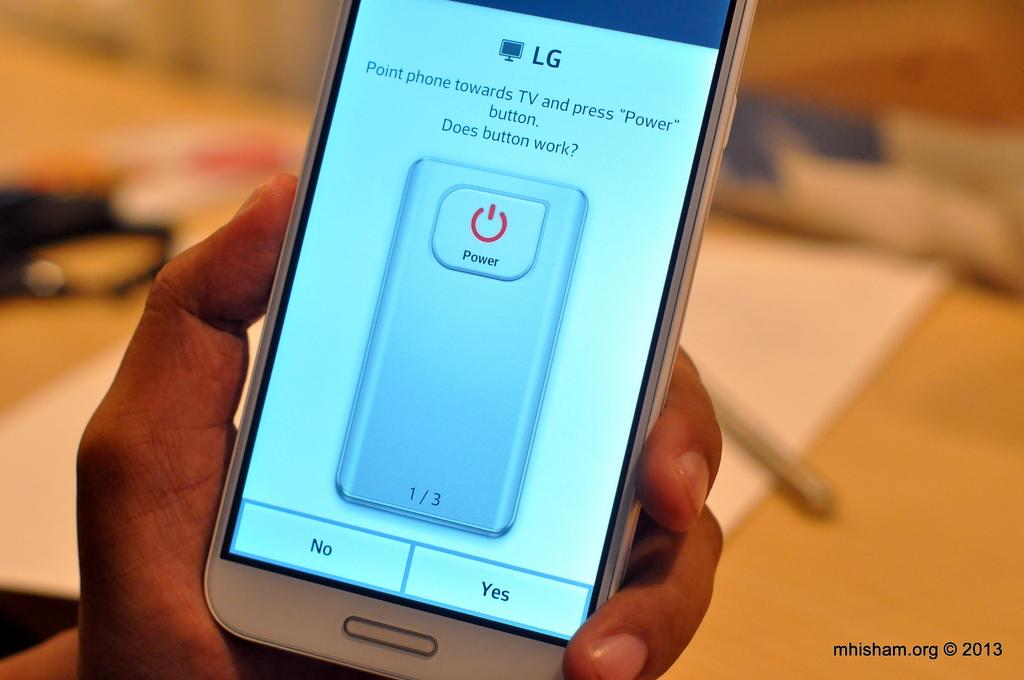<image>
Write a terse but informative summary of the picture. An LG brand phone offers instructions to link it to the TV. 